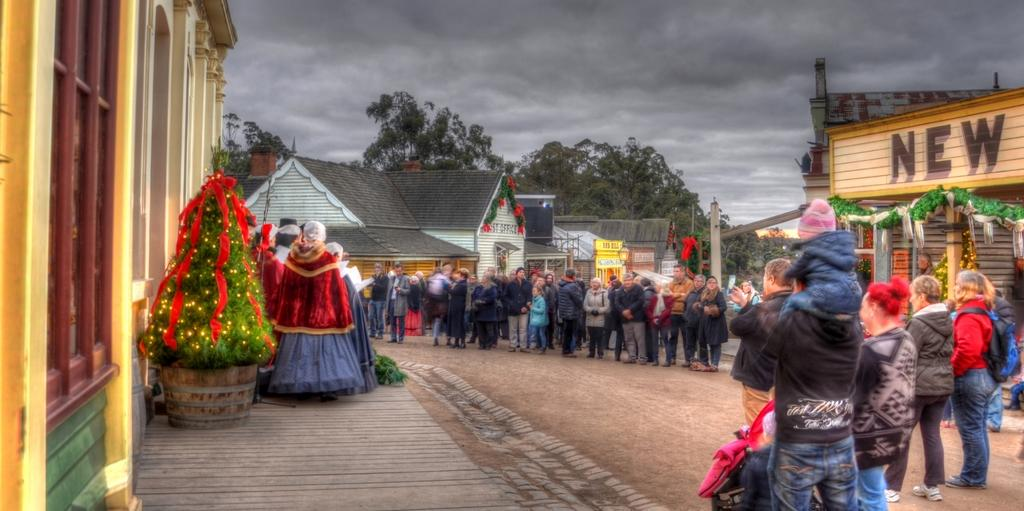Who or what can be seen in the image? There are people in the image. What is located on the left side of the image? There is a Christmas tree with decoratively decorated with decorative items on the left side of the image. What architectural feature is present in the image? There is a window in the image. What can be seen in the distance in the image? Houses and trees are visible in the background of the image. How would you describe the weather based on the image? The sky is cloudy in the image. What is the rate of the blade spinning in the image? There is no blade present in the image, so it is not possible to determine its rate of spinning. 